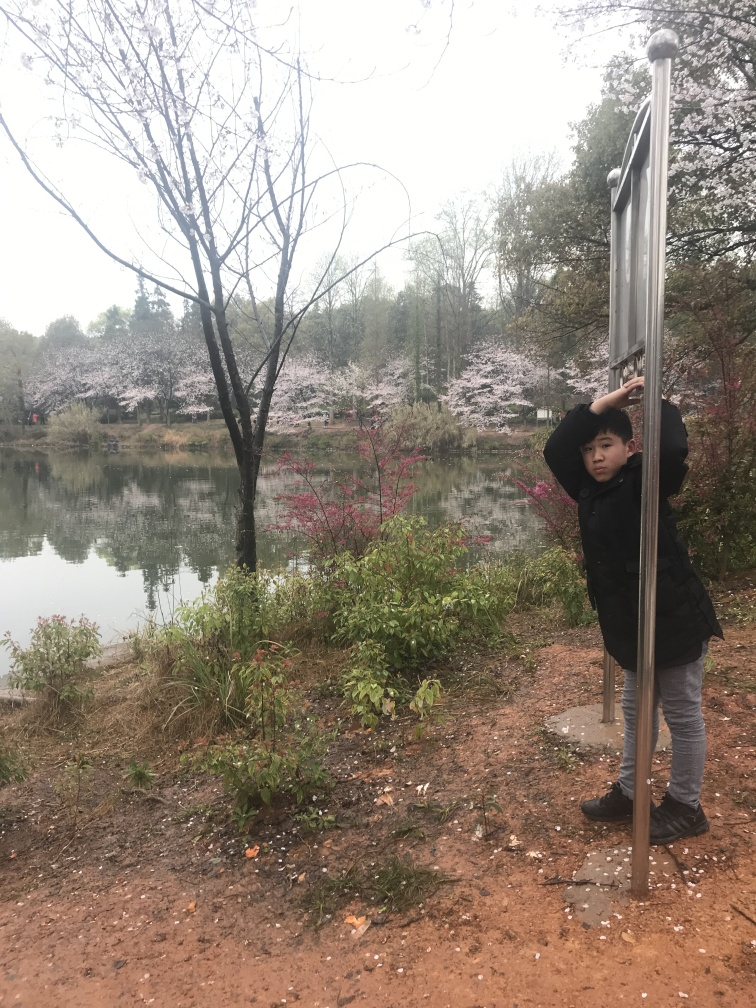Can you describe the activities you think could take place in a setting like this? In such a picturesque setting, one could imagine activities such as leisurely walks around the pond, photography, picnicking under the trees, or simply sitting and enjoying the natural surroundings. The presence of the person near the pole suggests a playful exploration, and one could also envision children playing hide and seek or engaging in gentle play by the water's edge. 